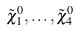Convert formula to latex. <formula><loc_0><loc_0><loc_500><loc_500>\tilde { \chi } _ { 1 } ^ { 0 } , \dots , \tilde { \chi } _ { 4 } ^ { 0 }</formula> 